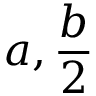<formula> <loc_0><loc_0><loc_500><loc_500>a , { \frac { b } { 2 } }</formula> 